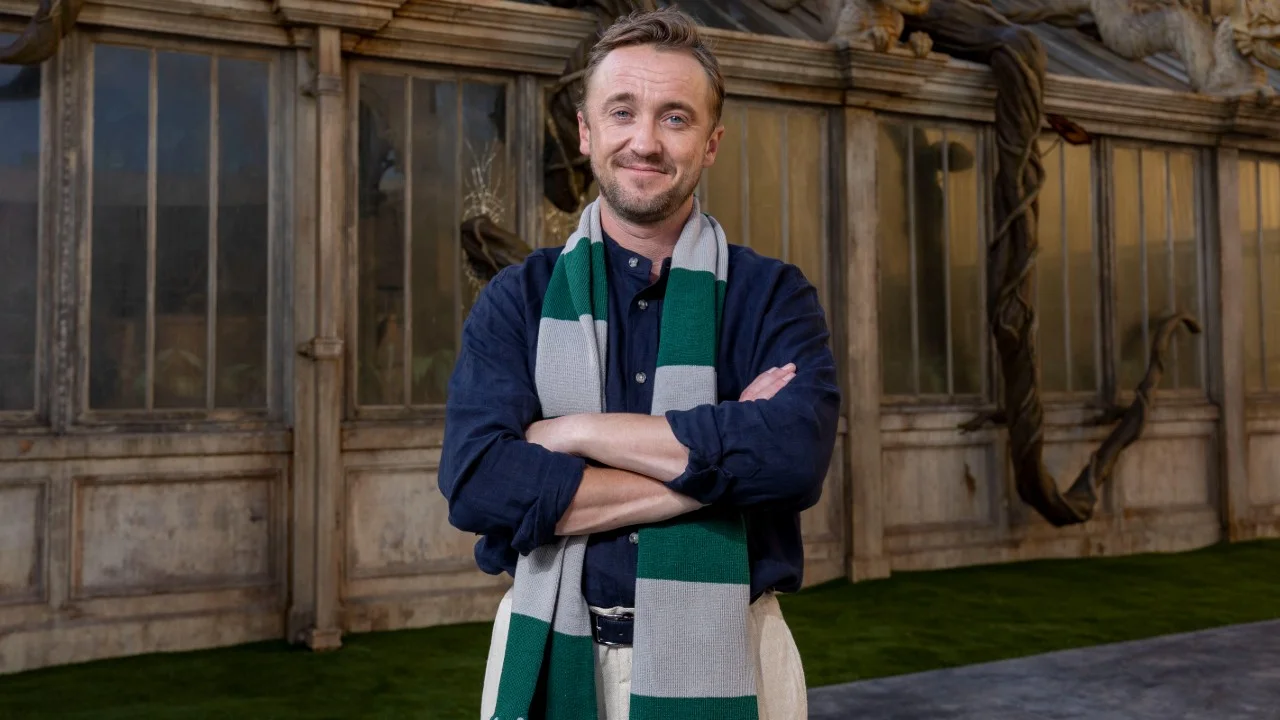Describe the historical significance of the architecture in the backdrop. The architecture in the backdrop of the image features weathered stone walls and large, framed windows, characteristic of Gothic Revival architecture often seen in historic and institutional buildings. The coiling, plant-like structures add a layer of organic complexity, which may symbolize the intertwining of nature and human craftsmanship. This architectural style, popular in the 19th century, sought to revive elements of Gothic architecture such as pointed arches, intricate tracery, and a focus on verticality, invoking a sense of grandeur and timelessness. How does the setting contribute to the overall mood of the image? The setting greatly enhances the overall mood of the image, creating a serene and reflective atmosphere. The juxtaposition of the stone walls and large windows with the softer greenery in the background provides a balance between strength and tranquility. The natural elements creeping up the walls introduce a sense of continuity and growth, suggesting that the environment is one that fosters introspection and silent contemplation. This harmonious blend of nature and architecture creates a tranquil yet majestic ambiance that complements the subject’s calm and thoughtful expression. 